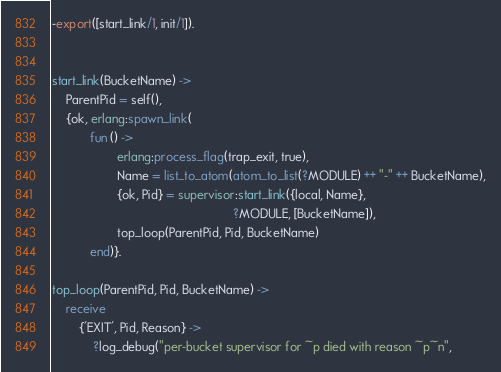<code> <loc_0><loc_0><loc_500><loc_500><_Erlang_>
-export([start_link/1, init/1]).


start_link(BucketName) ->
    ParentPid = self(),
    {ok, erlang:spawn_link(
           fun () ->
                   erlang:process_flag(trap_exit, true),
                   Name = list_to_atom(atom_to_list(?MODULE) ++ "-" ++ BucketName),
                   {ok, Pid} = supervisor:start_link({local, Name},
                                                     ?MODULE, [BucketName]),
                   top_loop(ParentPid, Pid, BucketName)
           end)}.

top_loop(ParentPid, Pid, BucketName) ->
    receive
        {'EXIT', Pid, Reason} ->
            ?log_debug("per-bucket supervisor for ~p died with reason ~p~n",</code> 